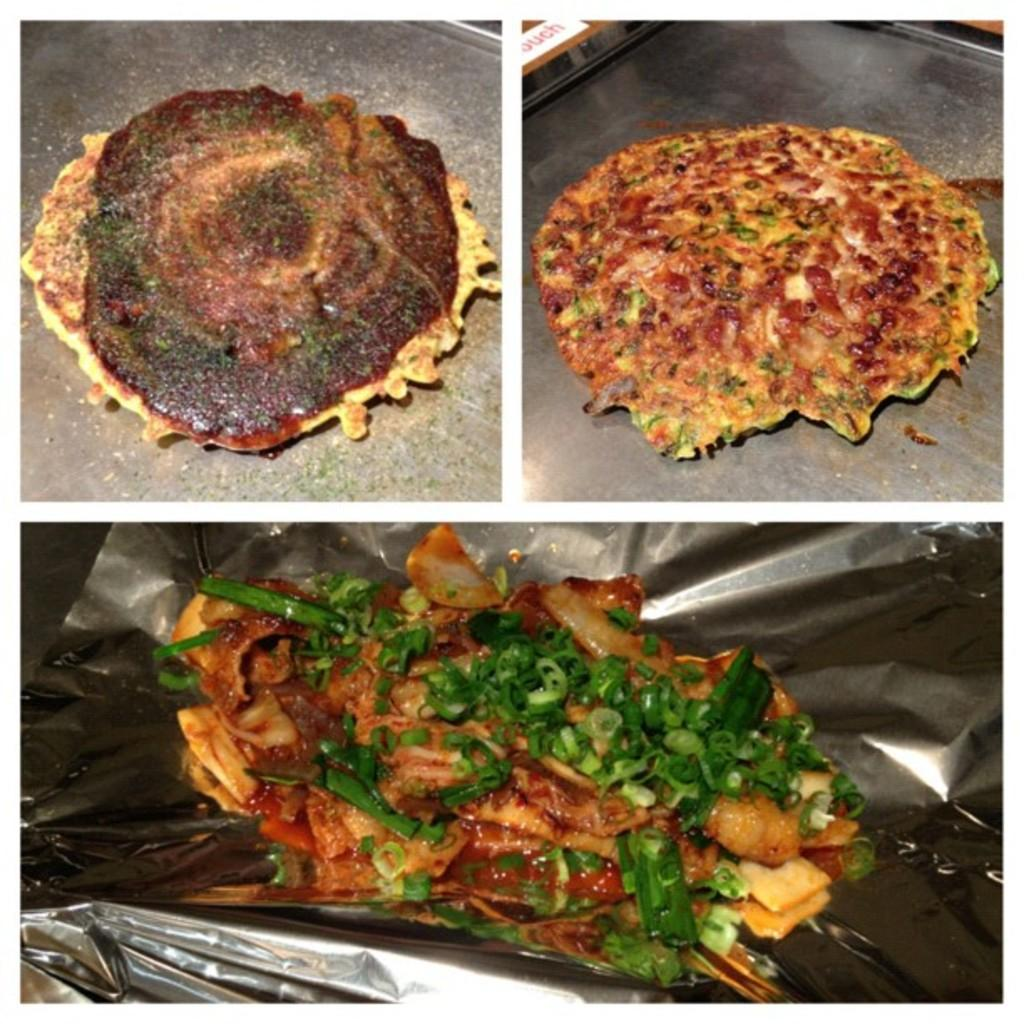What types of items can be seen in the image? There are food items in the image. Are there any beads used as decorations for the party in the image? There is no mention of a party or beads in the image; it only contains food items. 